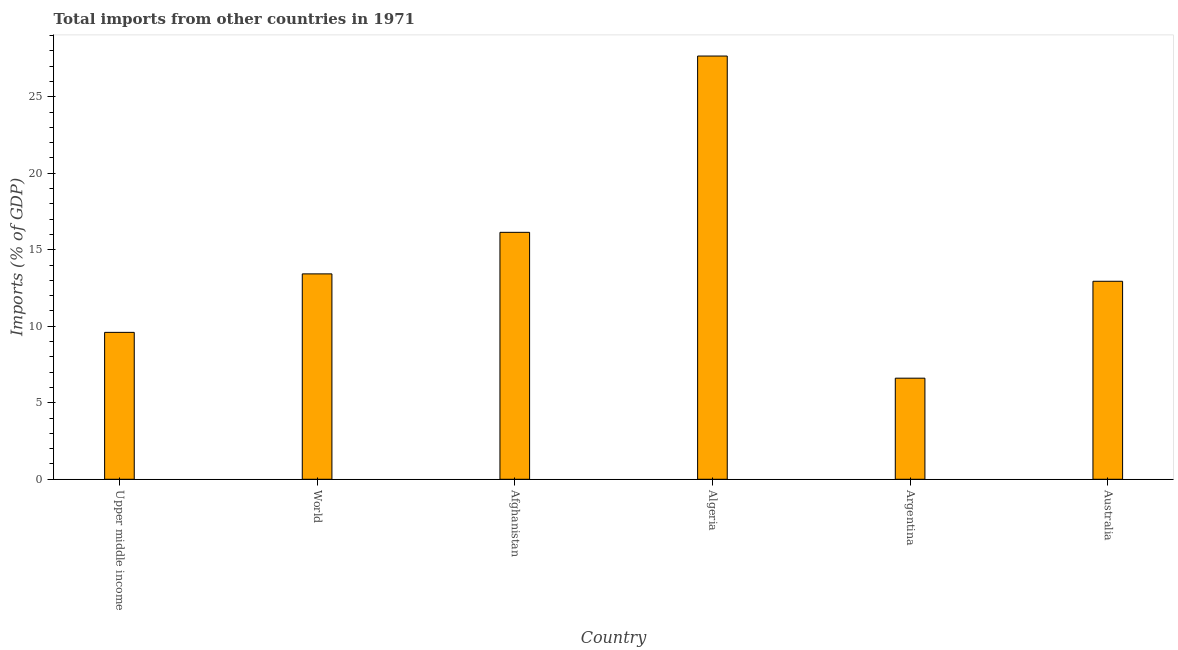Does the graph contain any zero values?
Ensure brevity in your answer.  No. Does the graph contain grids?
Ensure brevity in your answer.  No. What is the title of the graph?
Give a very brief answer. Total imports from other countries in 1971. What is the label or title of the Y-axis?
Give a very brief answer. Imports (% of GDP). What is the total imports in Afghanistan?
Your answer should be compact. 16.14. Across all countries, what is the maximum total imports?
Your response must be concise. 27.66. Across all countries, what is the minimum total imports?
Your answer should be compact. 6.61. In which country was the total imports maximum?
Your response must be concise. Algeria. In which country was the total imports minimum?
Your answer should be compact. Argentina. What is the sum of the total imports?
Ensure brevity in your answer.  86.38. What is the difference between the total imports in Australia and World?
Your response must be concise. -0.48. What is the average total imports per country?
Your response must be concise. 14.4. What is the median total imports?
Offer a terse response. 13.18. What is the ratio of the total imports in Afghanistan to that in Algeria?
Offer a very short reply. 0.58. What is the difference between the highest and the second highest total imports?
Your response must be concise. 11.52. Is the sum of the total imports in Algeria and Upper middle income greater than the maximum total imports across all countries?
Offer a terse response. Yes. What is the difference between the highest and the lowest total imports?
Your answer should be compact. 21.06. In how many countries, is the total imports greater than the average total imports taken over all countries?
Make the answer very short. 2. How many bars are there?
Ensure brevity in your answer.  6. Are all the bars in the graph horizontal?
Your answer should be very brief. No. How many countries are there in the graph?
Provide a succinct answer. 6. What is the Imports (% of GDP) of Upper middle income?
Keep it short and to the point. 9.6. What is the Imports (% of GDP) in World?
Give a very brief answer. 13.43. What is the Imports (% of GDP) in Afghanistan?
Your answer should be compact. 16.14. What is the Imports (% of GDP) in Algeria?
Offer a very short reply. 27.66. What is the Imports (% of GDP) in Argentina?
Your response must be concise. 6.61. What is the Imports (% of GDP) in Australia?
Provide a succinct answer. 12.94. What is the difference between the Imports (% of GDP) in Upper middle income and World?
Give a very brief answer. -3.82. What is the difference between the Imports (% of GDP) in Upper middle income and Afghanistan?
Keep it short and to the point. -6.54. What is the difference between the Imports (% of GDP) in Upper middle income and Algeria?
Ensure brevity in your answer.  -18.06. What is the difference between the Imports (% of GDP) in Upper middle income and Argentina?
Make the answer very short. 2.99. What is the difference between the Imports (% of GDP) in Upper middle income and Australia?
Ensure brevity in your answer.  -3.34. What is the difference between the Imports (% of GDP) in World and Afghanistan?
Ensure brevity in your answer.  -2.72. What is the difference between the Imports (% of GDP) in World and Algeria?
Give a very brief answer. -14.24. What is the difference between the Imports (% of GDP) in World and Argentina?
Offer a very short reply. 6.82. What is the difference between the Imports (% of GDP) in World and Australia?
Your response must be concise. 0.48. What is the difference between the Imports (% of GDP) in Afghanistan and Algeria?
Ensure brevity in your answer.  -11.52. What is the difference between the Imports (% of GDP) in Afghanistan and Argentina?
Provide a succinct answer. 9.53. What is the difference between the Imports (% of GDP) in Afghanistan and Australia?
Your answer should be compact. 3.2. What is the difference between the Imports (% of GDP) in Algeria and Argentina?
Make the answer very short. 21.06. What is the difference between the Imports (% of GDP) in Algeria and Australia?
Keep it short and to the point. 14.72. What is the difference between the Imports (% of GDP) in Argentina and Australia?
Keep it short and to the point. -6.33. What is the ratio of the Imports (% of GDP) in Upper middle income to that in World?
Your answer should be compact. 0.71. What is the ratio of the Imports (% of GDP) in Upper middle income to that in Afghanistan?
Your answer should be compact. 0.59. What is the ratio of the Imports (% of GDP) in Upper middle income to that in Algeria?
Offer a very short reply. 0.35. What is the ratio of the Imports (% of GDP) in Upper middle income to that in Argentina?
Give a very brief answer. 1.45. What is the ratio of the Imports (% of GDP) in Upper middle income to that in Australia?
Keep it short and to the point. 0.74. What is the ratio of the Imports (% of GDP) in World to that in Afghanistan?
Provide a succinct answer. 0.83. What is the ratio of the Imports (% of GDP) in World to that in Algeria?
Offer a terse response. 0.48. What is the ratio of the Imports (% of GDP) in World to that in Argentina?
Give a very brief answer. 2.03. What is the ratio of the Imports (% of GDP) in World to that in Australia?
Provide a short and direct response. 1.04. What is the ratio of the Imports (% of GDP) in Afghanistan to that in Algeria?
Your answer should be compact. 0.58. What is the ratio of the Imports (% of GDP) in Afghanistan to that in Argentina?
Your response must be concise. 2.44. What is the ratio of the Imports (% of GDP) in Afghanistan to that in Australia?
Give a very brief answer. 1.25. What is the ratio of the Imports (% of GDP) in Algeria to that in Argentina?
Keep it short and to the point. 4.19. What is the ratio of the Imports (% of GDP) in Algeria to that in Australia?
Keep it short and to the point. 2.14. What is the ratio of the Imports (% of GDP) in Argentina to that in Australia?
Your response must be concise. 0.51. 